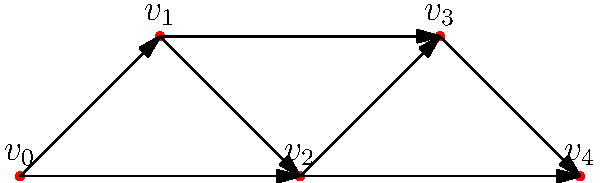Given the directed graph representing user navigation patterns through a jQuery menu, what is the out-degree of vertex $v_2$, and how might this information be useful for optimizing menu structure? To answer this question, let's follow these steps:

1. Understand the concept of out-degree:
   The out-degree of a vertex in a directed graph is the number of edges pointing outward from that vertex.

2. Analyze vertex $v_2$:
   Looking at the graph, we can see that vertex $v_2$ has two edges pointing outward:
   - One edge going to vertex $v_3$
   - One edge going to vertex $v_4$

3. Count the out-degree:
   The out-degree of vertex $v_2$ is 2.

4. Interpret the result:
   An out-degree of 2 for $v_2$ means that users at this menu point have two options to navigate further.

5. Application to menu optimization:
   - High out-degree: Indicates many options, which might overwhelm users.
   - Low out-degree: Suggests a more streamlined navigation but might require more steps to reach destinations.
   - Balanced out-degree: Aims for an optimal number of choices at each level.

6. For jQuery menu integration:
   - Use this information to structure menus with an appropriate number of items.
   - Implement event listeners on menu items corresponding to edges in the graph.
   - Consider using jQuery's animation features for smooth transitions between menu states.

By analyzing out-degrees across the menu structure, front-end developers can create more intuitive and user-friendly navigation patterns in their jQuery menus.
Answer: 2; guides menu structure optimization 